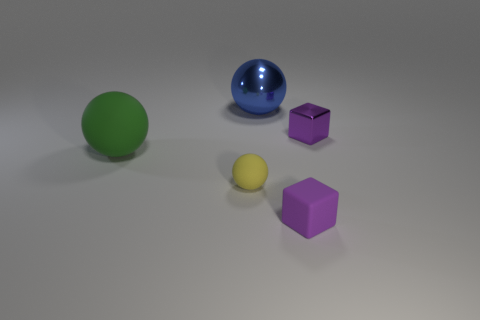Are there fewer yellow spheres to the right of the small purple matte block than tiny purple blocks left of the tiny yellow matte ball?
Provide a succinct answer. No. There is another block that is the same color as the metal block; what is it made of?
Offer a very short reply. Rubber. Is there any other thing that is the same shape as the green thing?
Offer a very short reply. Yes. There is a big object right of the small yellow matte ball; what material is it?
Keep it short and to the point. Metal. Is the number of cyan rubber things the same as the number of small rubber balls?
Provide a succinct answer. No. Is there any other thing that has the same size as the metal ball?
Your answer should be very brief. Yes. Are there any blue metallic objects right of the tiny purple metal thing?
Give a very brief answer. No. What shape is the tiny purple metal object?
Offer a terse response. Cube. How many things are either yellow rubber spheres that are in front of the big green object or large balls?
Provide a short and direct response. 3. What number of other objects are the same color as the big metallic thing?
Your answer should be compact. 0. 